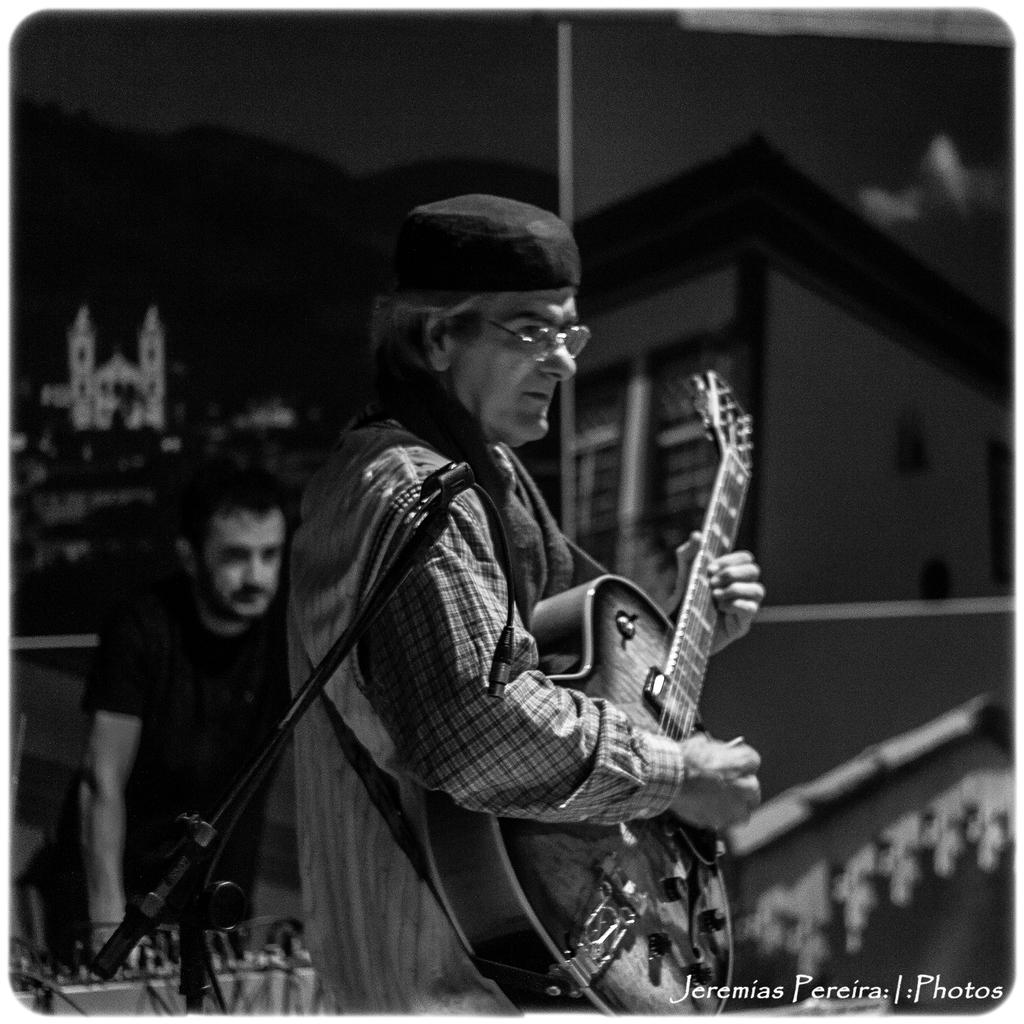What is the main subject of the image? There is a person standing in the image. What is the person doing in the image? The person is playing a guitar. Can you describe the person behind the guitar player? There is another person behind the guitar player. What object is present in the front of the image? A microphone is present in the front of the image. What is the weight of the train that can be seen in the image? There is no train present in the image, so it is not possible to determine its weight. 